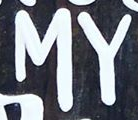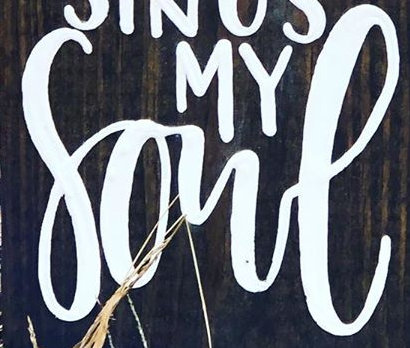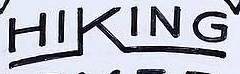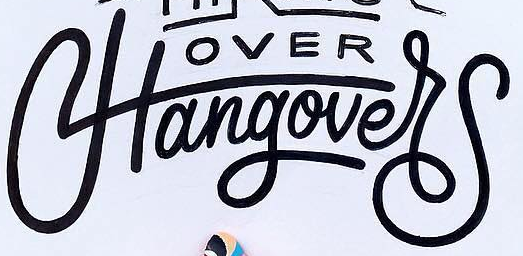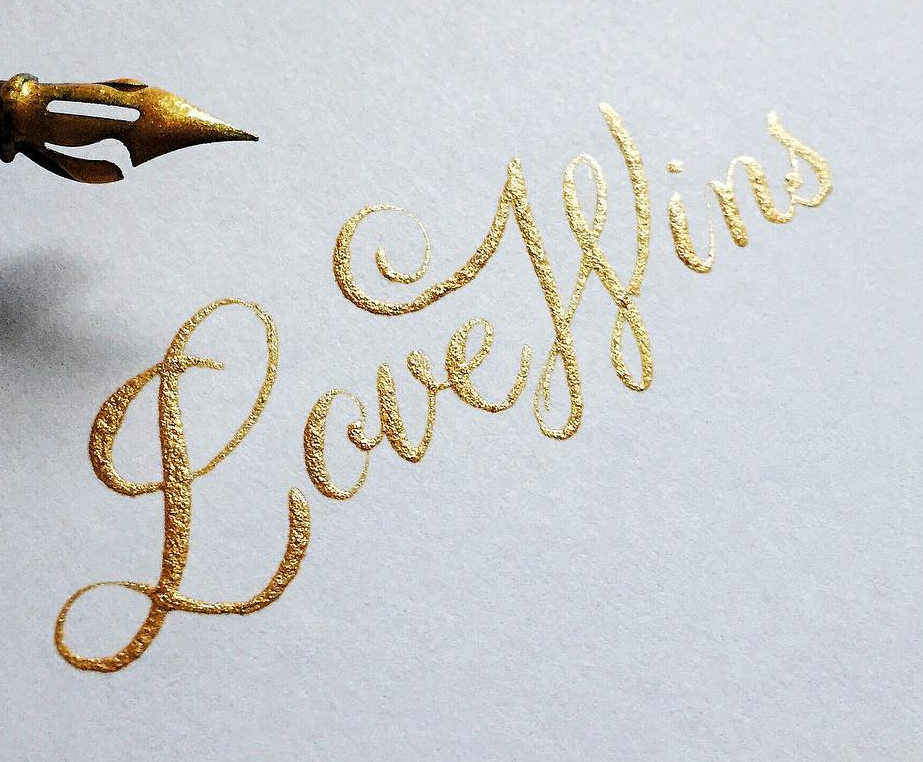Read the text content from these images in order, separated by a semicolon. MY; Sone; HIKING; Hangover; LoveWins 